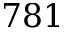Convert formula to latex. <formula><loc_0><loc_0><loc_500><loc_500>7 8 1</formula> 